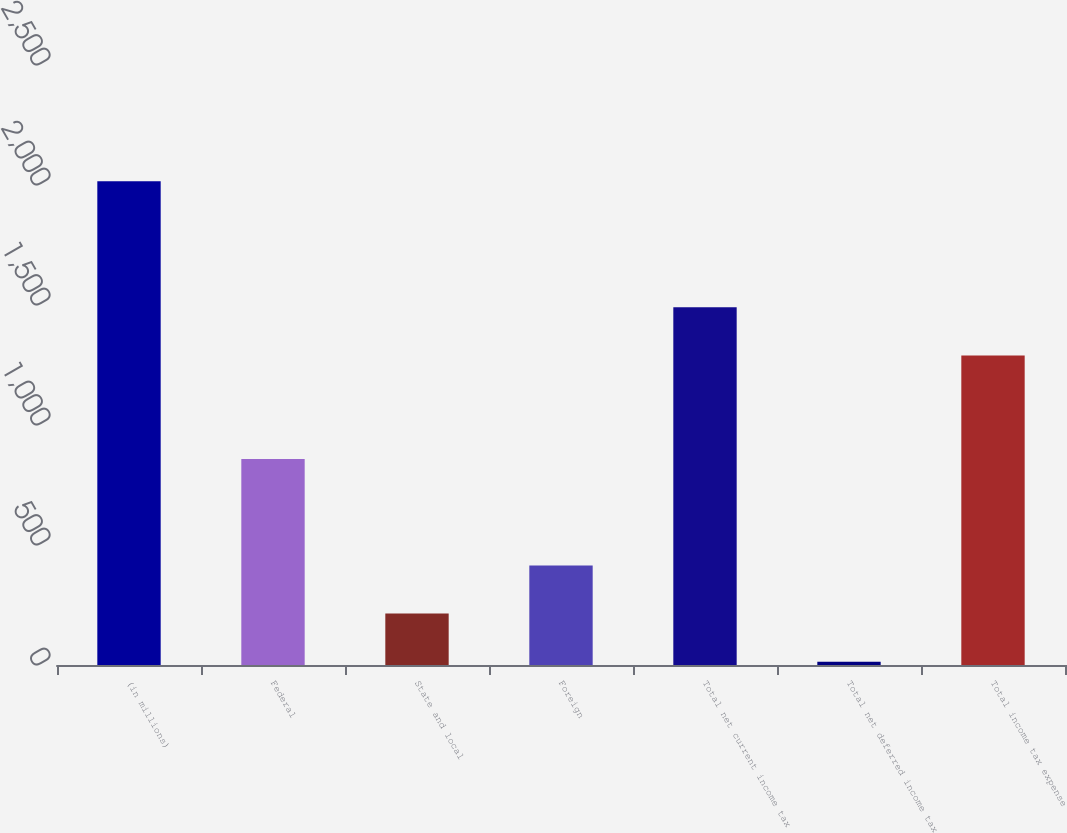Convert chart. <chart><loc_0><loc_0><loc_500><loc_500><bar_chart><fcel>(in millions)<fcel>Federal<fcel>State and local<fcel>Foreign<fcel>Total net current income tax<fcel>Total net deferred income tax<fcel>Total income tax expense<nl><fcel>2016<fcel>858<fcel>214.2<fcel>414.4<fcel>1490.2<fcel>14<fcel>1290<nl></chart> 